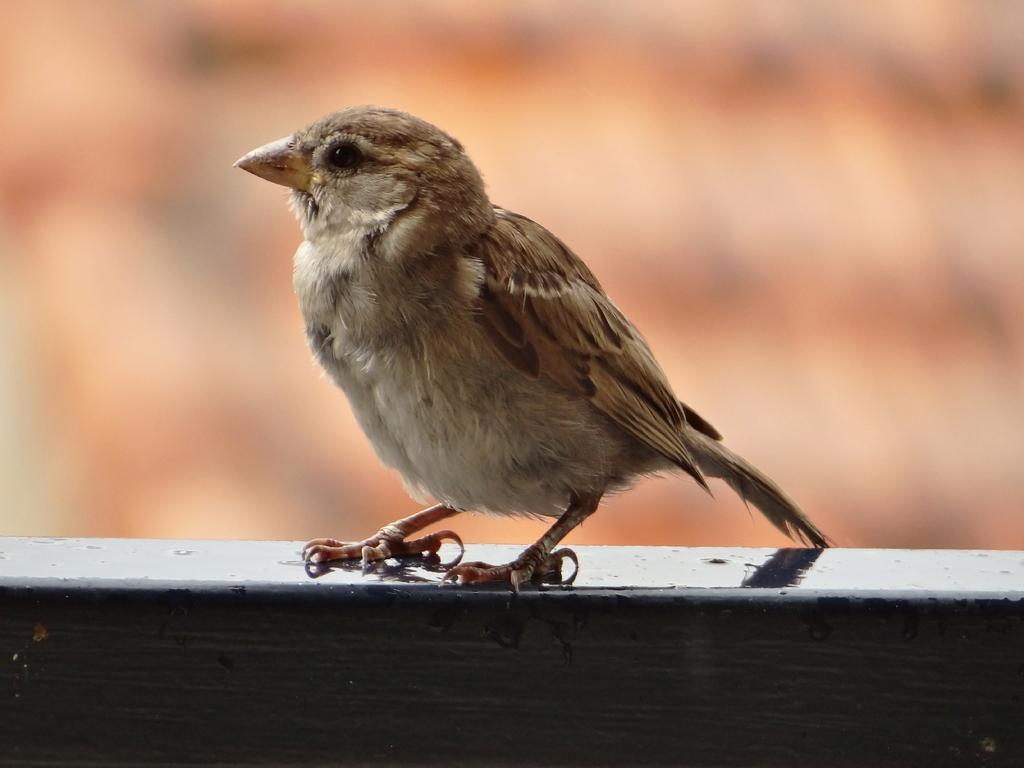What type of animal is present in the image? There is a bird in the image. What color is the background behind the bird? The background of the bird is blue. What type of tools does the bird use in the competition to showcase its wealth? There is no competition or mention of wealth in the image; it simply features a bird with a blue background. 